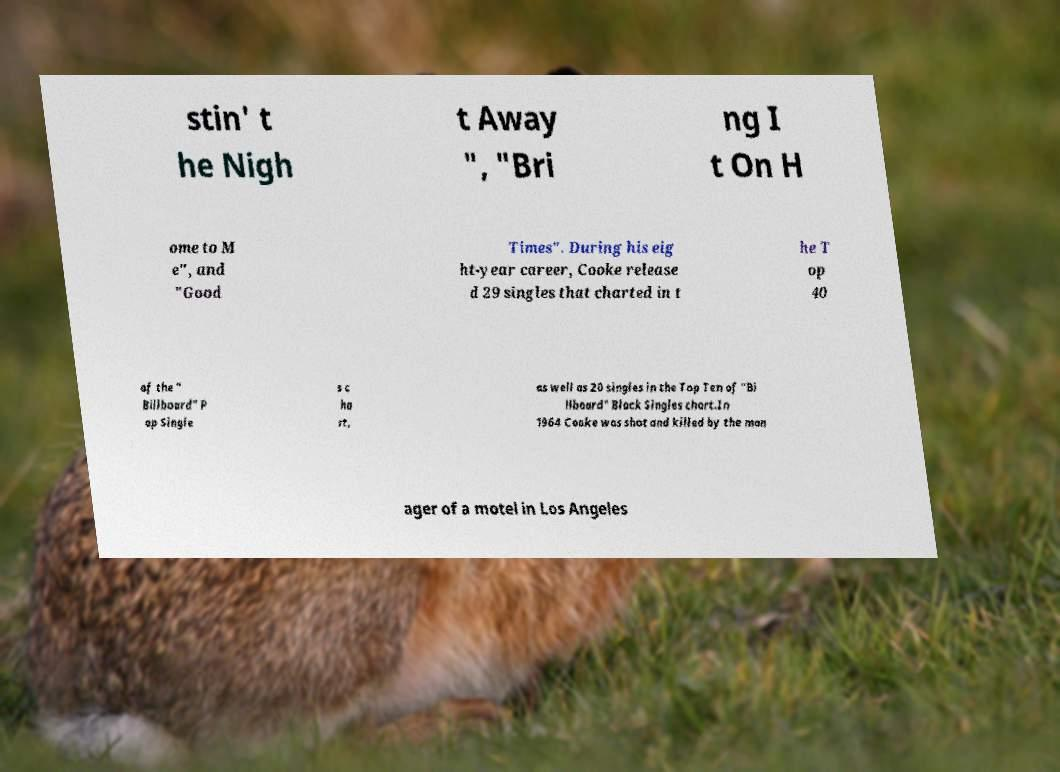What messages or text are displayed in this image? I need them in a readable, typed format. stin' t he Nigh t Away ", "Bri ng I t On H ome to M e", and "Good Times". During his eig ht-year career, Cooke release d 29 singles that charted in t he T op 40 of the " Billboard" P op Single s c ha rt, as well as 20 singles in the Top Ten of "Bi llboard" Black Singles chart.In 1964 Cooke was shot and killed by the man ager of a motel in Los Angeles 